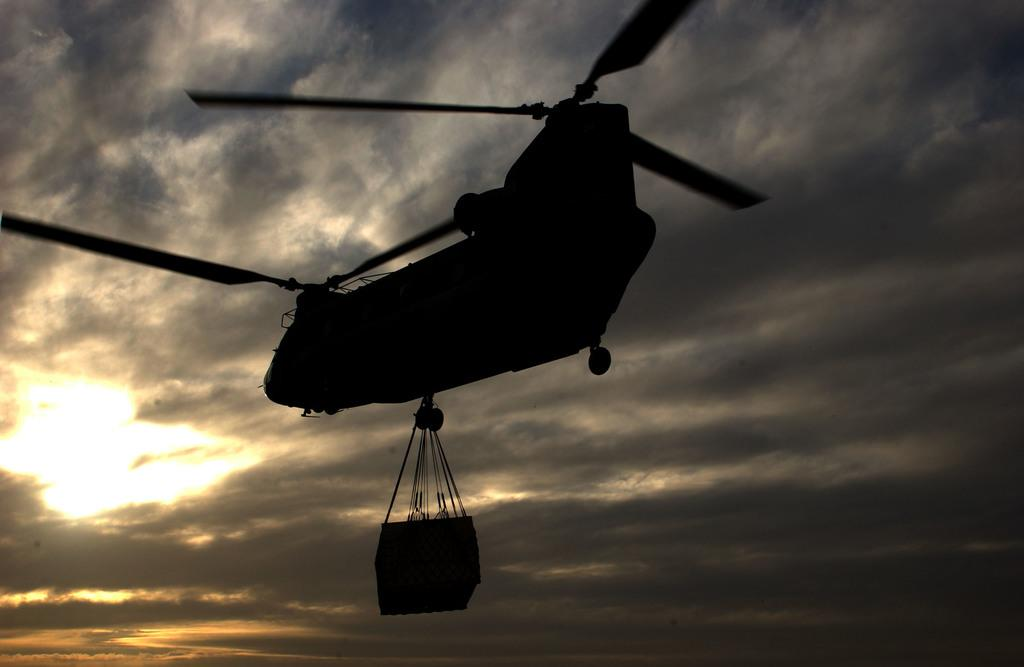What is the weather like in the image? The sky in the image is cloudy. What is the main subject in the image? There is an aircraft in the image. What is the aircraft doing in the image? The aircraft is carrying an object. Can you see any sunlight in the image? Yes, sunshine is visible in the image. Where is the toothbrush located in the image? There is no toothbrush present in the image. Can you describe the grandmother's outfit in the image? There is no grandmother present in the image. 